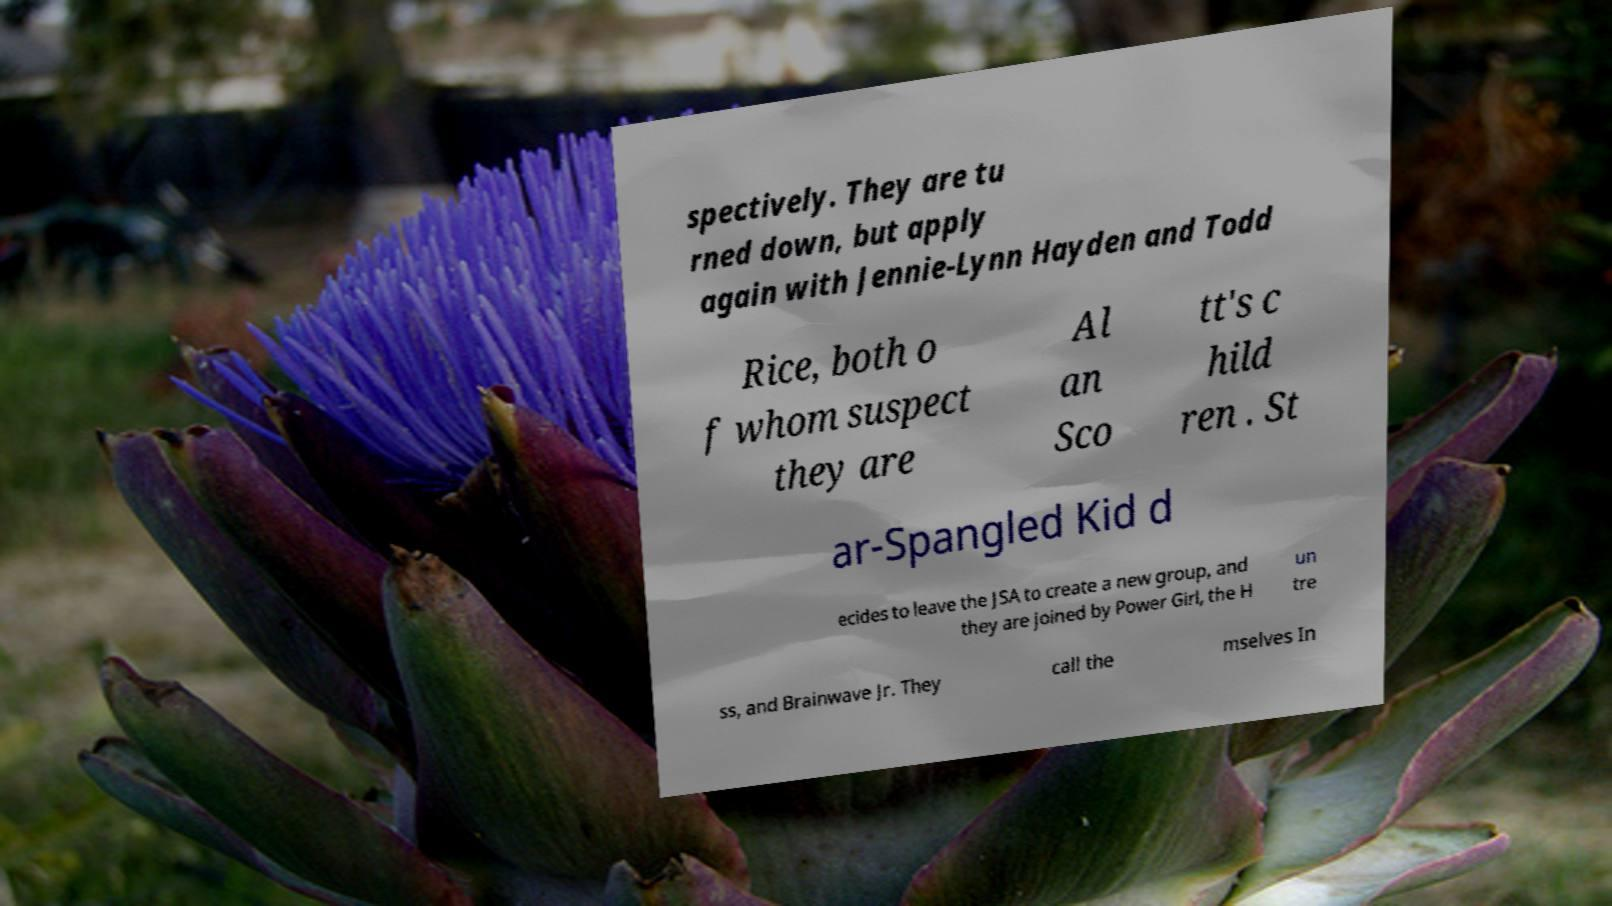Please identify and transcribe the text found in this image. spectively. They are tu rned down, but apply again with Jennie-Lynn Hayden and Todd Rice, both o f whom suspect they are Al an Sco tt's c hild ren . St ar-Spangled Kid d ecides to leave the JSA to create a new group, and they are joined by Power Girl, the H un tre ss, and Brainwave Jr. They call the mselves In 